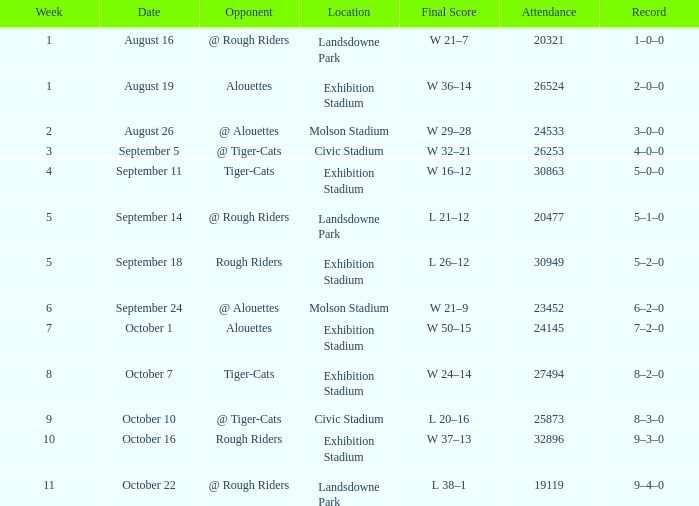How many dates for the week of 4? 1.0. 